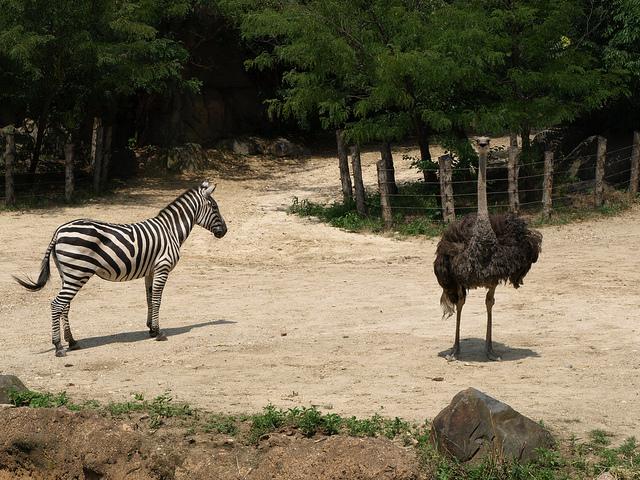Can you see any trees?
Answer briefly. Yes. How many boulders are in front of the ostrich?
Give a very brief answer. 1. What kind of animal is in the picture?
Write a very short answer. Zebra. What kind of animal is shown?
Quick response, please. Zebra and ostrich. Does the ostrich fly?
Give a very brief answer. No. 